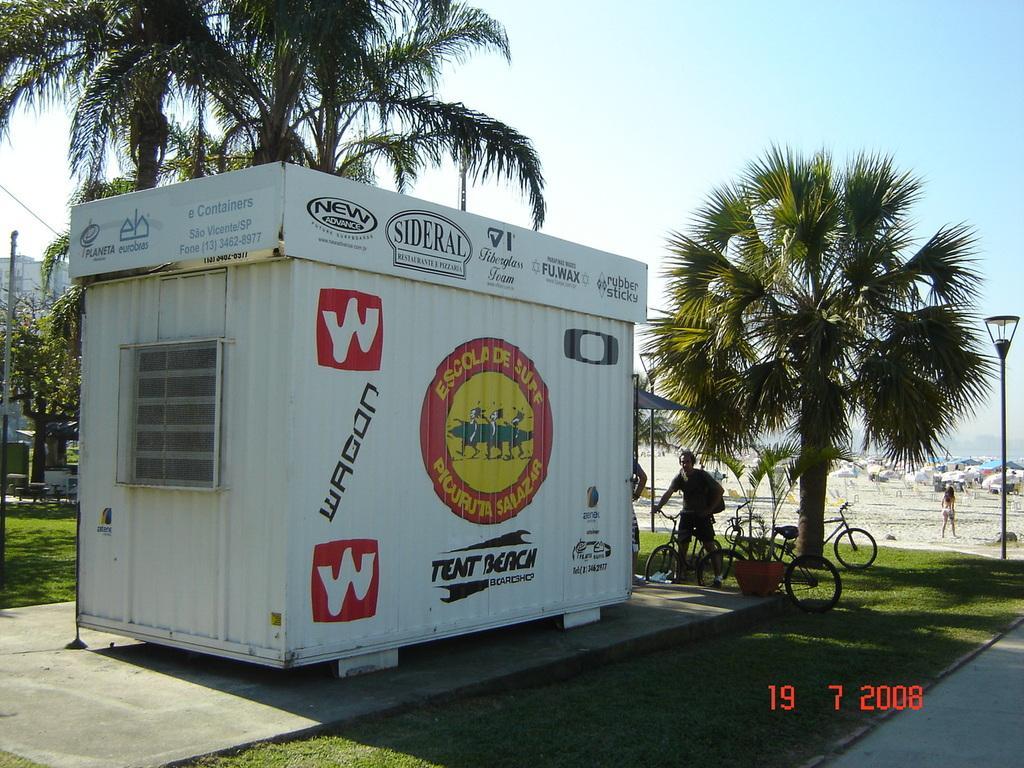How would you summarize this image in a sentence or two? In this image there is a shop on the floor. Few bicycles are on the grassland. A person is holding a bicycle and he is standing on the grass land. Beside him there is a person standing. A person is walking on the land. There is a street light on the grassland. Background there are few trees. Left side there is a building. Top of the image there is sky. 